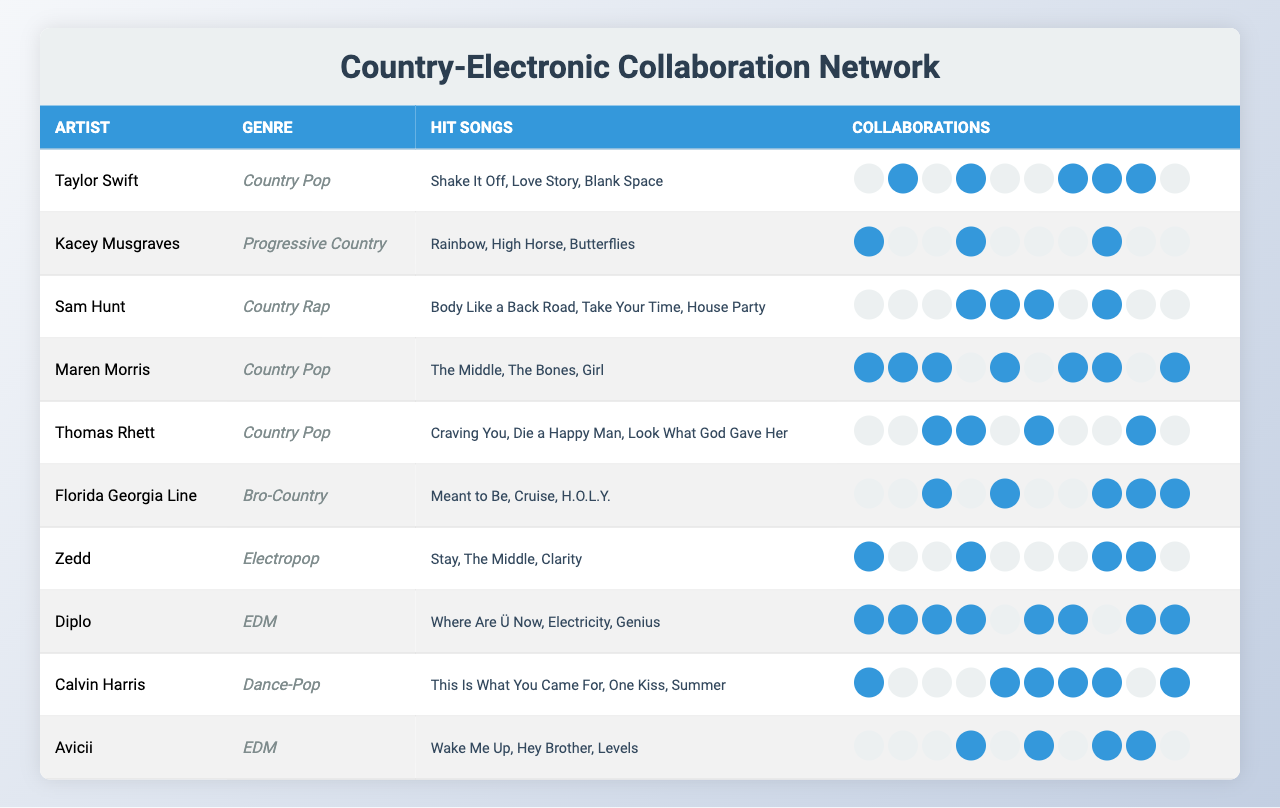What is the genre of Taylor Swift? The genre of Taylor Swift is listed in the second column of the table, which indicates that she is classified as "Country Pop."
Answer: Country Pop How many hit songs does Kacey Musgraves have? The hit songs for Kacey Musgraves are presented in the third column, and they include "Rainbow," "High Horse," and "Butterflies," totaling three hit songs.
Answer: 3 Which artist has collaborated the most? By analyzing the collaborations for each artist, I find that Florida Georgia Line has collaborated with other artists a total of 6 times, indicated by the number of filled collaboration cells in their row.
Answer: Florida Georgia Line Does Sam Hunt have any collaborations with EDM artists? The collaborations row for Sam Hunt shows collaborations with artists such as Zedd and Diplo, who are identified under the EDM genre. Thus, Sam Hunt does have collaborations with EDM artists.
Answer: Yes Which country artist has collaborated with the most electronic producers? By reviewing the collaboration counts specifically with electronic producers (Zedd, Diplo, Calvin Harris, Avicii), I can see that Maren Morris has collaborated with three electronic producers, making her the country artist with the most collaborations in this genre.
Answer: Maren Morris How many total collaborations does Maren Morris have? The total number of collaborations for Maren Morris can be found by tallying the filled collaboration cells in her row. She has 6 total collaborations with other artists.
Answer: 6 Which electronic producer has the most collaborations with country artists? From the table, Diplo shows a total of 4 collaborations with country artists, which is more than any other electronic producer listed.
Answer: Diplo What is the average number of collaborations for all artists? To find the average, I sum the collaboration counts for all artists (totaling 28) and divide by the number of artists (10). This gives me an average of 2.8 collaborations per artist.
Answer: 2.8 Is it true that Kacey Musgraves has collaborated with Thomas Rhett? Checking the collaboration data in the table, the entry indicates that there is no collaboration (0), so the statement is false.
Answer: False Who has the least collaborations among the electronic producers? By examining the collaboration counts of the electronic producers, Zedd has only collaborated with 2 country artists, which is the least among them.
Answer: Zedd 